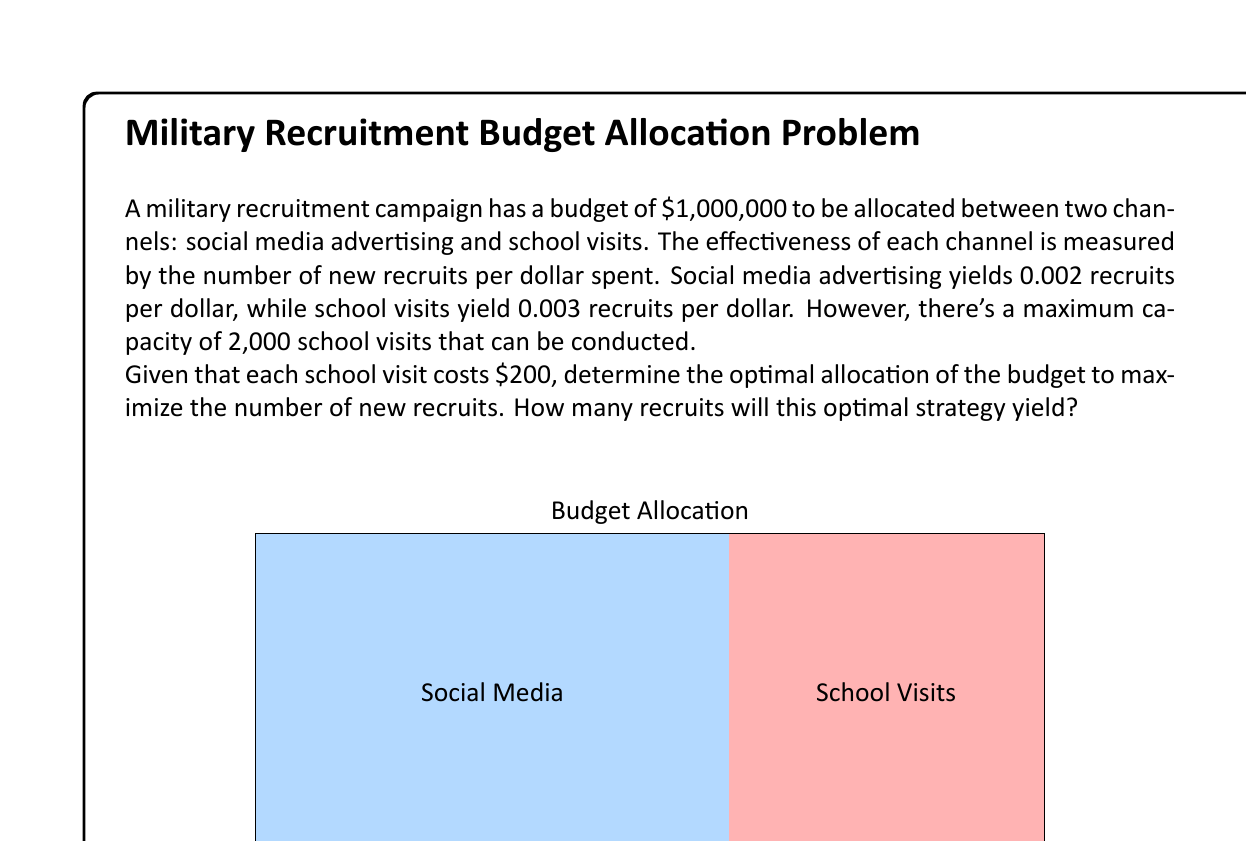Give your solution to this math problem. Let's approach this step-by-step:

1) First, we need to determine the maximum amount that can be spent on school visits:
   Maximum school visits = 2,000
   Cost per visit = $200
   Maximum budget for school visits = 2,000 * $200 = $400,000

2) Now, let's set up variables:
   Let $x$ be the amount spent on social media advertising
   Let $y$ be the amount spent on school visits

3) We can formulate our objective function to maximize recruits:
   $\text{Recruits} = 0.002x + 0.003y$

4) Our constraints are:
   $x + y \leq 1,000,000$ (total budget constraint)
   $y \leq 400,000$ (maximum school visits constraint)
   $x, y \geq 0$ (non-negativity constraints)

5) Given that school visits are more effective (0.003 > 0.002), we should allocate the maximum possible to school visits first:
   $y = 400,000$

6) The remaining budget goes to social media:
   $x = 1,000,000 - 400,000 = 600,000$

7) Now we can calculate the total number of recruits:
   $\text{Recruits} = 0.002(600,000) + 0.003(400,000)$
                    $= 1,200 + 1,200$
                    $= 2,400$

Therefore, the optimal allocation is $600,000 to social media advertising and $400,000 to school visits, yielding 2,400 recruits.
Answer: 2,400 recruits 